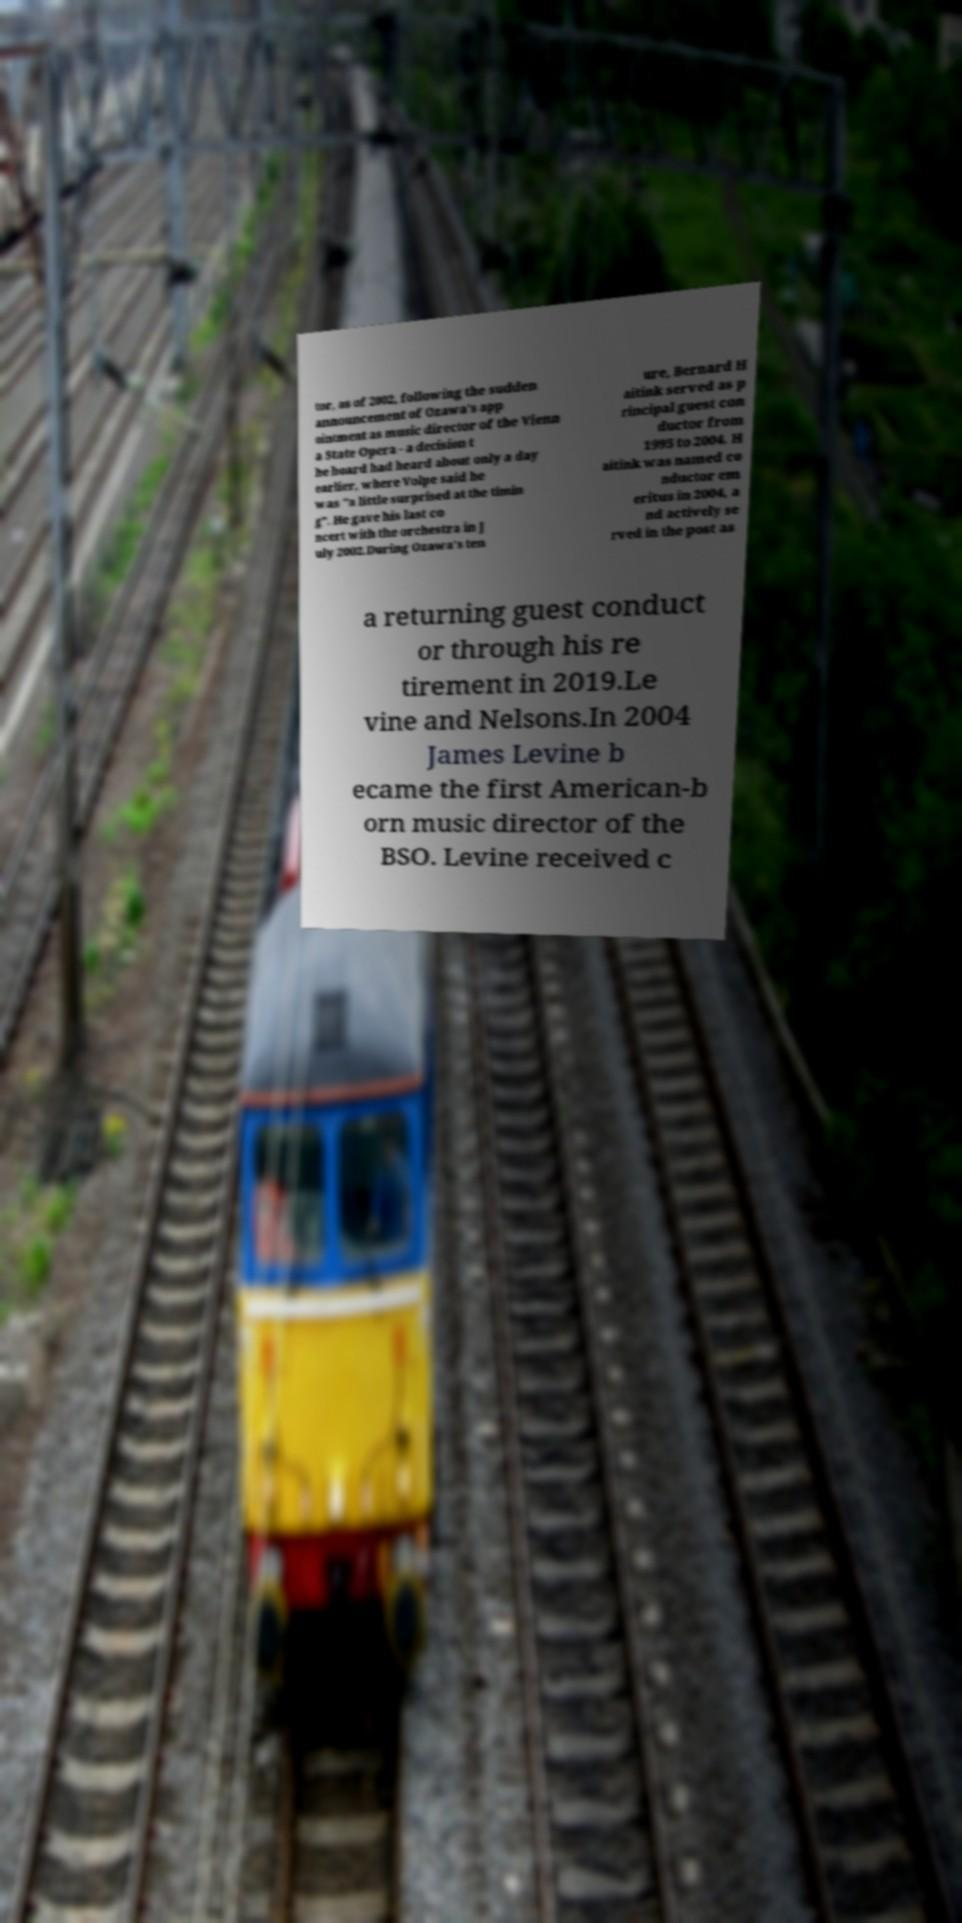There's text embedded in this image that I need extracted. Can you transcribe it verbatim? tor, as of 2002, following the sudden announcement of Ozawa's app ointment as music director of the Vienn a State Opera - a decision t he board had heard about only a day earlier, where Volpe said he was "a little surprised at the timin g". He gave his last co ncert with the orchestra in J uly 2002.During Ozawa's ten ure, Bernard H aitink served as p rincipal guest con ductor from 1995 to 2004. H aitink was named co nductor em eritus in 2004, a nd actively se rved in the post as a returning guest conduct or through his re tirement in 2019.Le vine and Nelsons.In 2004 James Levine b ecame the first American-b orn music director of the BSO. Levine received c 